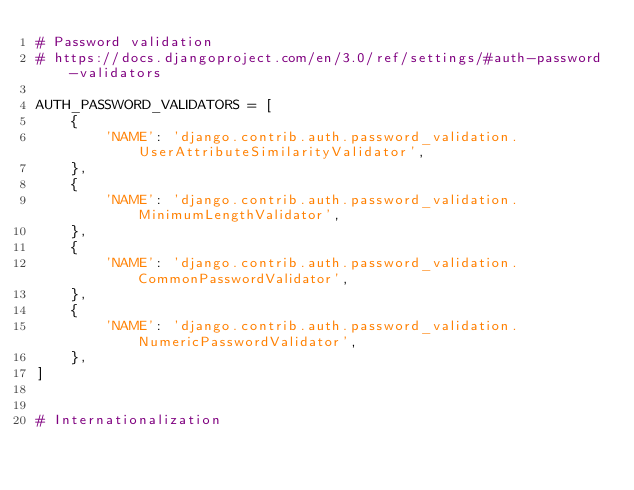<code> <loc_0><loc_0><loc_500><loc_500><_Python_># Password validation
# https://docs.djangoproject.com/en/3.0/ref/settings/#auth-password-validators

AUTH_PASSWORD_VALIDATORS = [
    {
        'NAME': 'django.contrib.auth.password_validation.UserAttributeSimilarityValidator',
    },
    {
        'NAME': 'django.contrib.auth.password_validation.MinimumLengthValidator',
    },
    {
        'NAME': 'django.contrib.auth.password_validation.CommonPasswordValidator',
    },
    {
        'NAME': 'django.contrib.auth.password_validation.NumericPasswordValidator',
    },
]


# Internationalization</code> 